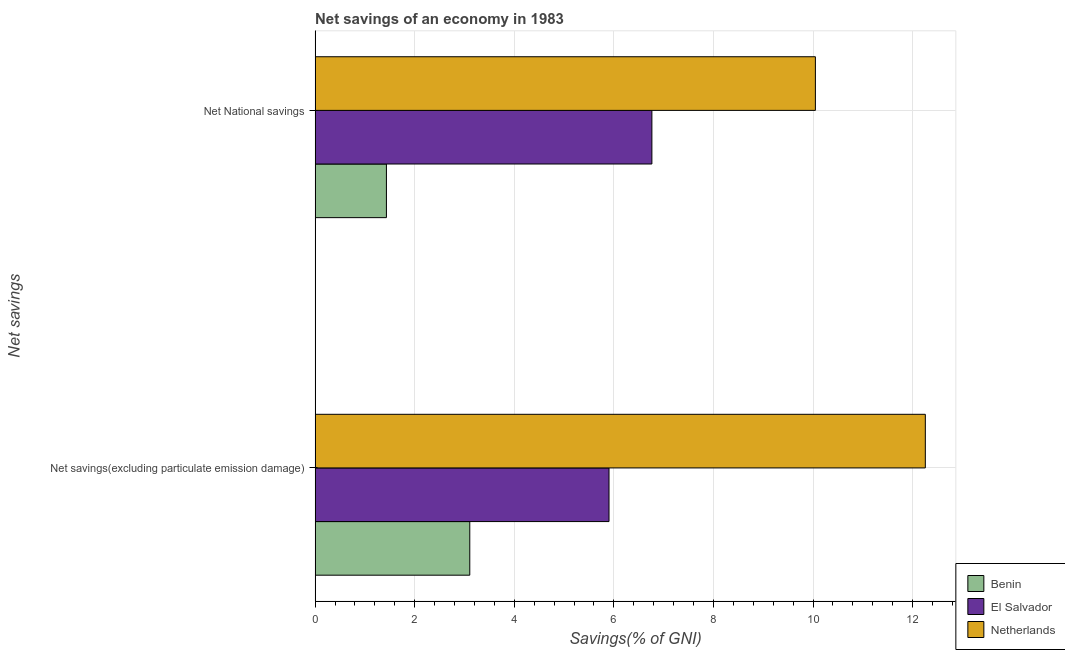How many groups of bars are there?
Offer a very short reply. 2. Are the number of bars on each tick of the Y-axis equal?
Provide a short and direct response. Yes. How many bars are there on the 1st tick from the top?
Make the answer very short. 3. What is the label of the 2nd group of bars from the top?
Provide a short and direct response. Net savings(excluding particulate emission damage). What is the net national savings in Netherlands?
Offer a terse response. 10.05. Across all countries, what is the maximum net savings(excluding particulate emission damage)?
Keep it short and to the point. 12.26. Across all countries, what is the minimum net national savings?
Make the answer very short. 1.43. In which country was the net national savings maximum?
Provide a succinct answer. Netherlands. In which country was the net savings(excluding particulate emission damage) minimum?
Your answer should be very brief. Benin. What is the total net national savings in the graph?
Your response must be concise. 18.24. What is the difference between the net savings(excluding particulate emission damage) in Benin and that in Netherlands?
Give a very brief answer. -9.15. What is the difference between the net national savings in Benin and the net savings(excluding particulate emission damage) in El Salvador?
Keep it short and to the point. -4.47. What is the average net savings(excluding particulate emission damage) per country?
Provide a succinct answer. 7.09. What is the difference between the net savings(excluding particulate emission damage) and net national savings in El Salvador?
Your answer should be very brief. -0.86. In how many countries, is the net national savings greater than 12 %?
Offer a terse response. 0. What is the ratio of the net national savings in Netherlands to that in El Salvador?
Keep it short and to the point. 1.49. Is the net national savings in El Salvador less than that in Netherlands?
Ensure brevity in your answer.  Yes. In how many countries, is the net national savings greater than the average net national savings taken over all countries?
Offer a very short reply. 2. What does the 2nd bar from the bottom in Net savings(excluding particulate emission damage) represents?
Ensure brevity in your answer.  El Salvador. How many bars are there?
Offer a very short reply. 6. What is the difference between two consecutive major ticks on the X-axis?
Provide a short and direct response. 2. Are the values on the major ticks of X-axis written in scientific E-notation?
Offer a terse response. No. Does the graph contain any zero values?
Give a very brief answer. No. Does the graph contain grids?
Provide a succinct answer. Yes. Where does the legend appear in the graph?
Give a very brief answer. Bottom right. How many legend labels are there?
Your answer should be compact. 3. How are the legend labels stacked?
Ensure brevity in your answer.  Vertical. What is the title of the graph?
Your response must be concise. Net savings of an economy in 1983. Does "Liberia" appear as one of the legend labels in the graph?
Give a very brief answer. No. What is the label or title of the X-axis?
Your answer should be compact. Savings(% of GNI). What is the label or title of the Y-axis?
Provide a succinct answer. Net savings. What is the Savings(% of GNI) of Benin in Net savings(excluding particulate emission damage)?
Offer a very short reply. 3.11. What is the Savings(% of GNI) of El Salvador in Net savings(excluding particulate emission damage)?
Offer a very short reply. 5.9. What is the Savings(% of GNI) in Netherlands in Net savings(excluding particulate emission damage)?
Your answer should be very brief. 12.26. What is the Savings(% of GNI) of Benin in Net National savings?
Your answer should be very brief. 1.43. What is the Savings(% of GNI) of El Salvador in Net National savings?
Ensure brevity in your answer.  6.76. What is the Savings(% of GNI) in Netherlands in Net National savings?
Keep it short and to the point. 10.05. Across all Net savings, what is the maximum Savings(% of GNI) in Benin?
Make the answer very short. 3.11. Across all Net savings, what is the maximum Savings(% of GNI) of El Salvador?
Your answer should be compact. 6.76. Across all Net savings, what is the maximum Savings(% of GNI) of Netherlands?
Keep it short and to the point. 12.26. Across all Net savings, what is the minimum Savings(% of GNI) in Benin?
Offer a terse response. 1.43. Across all Net savings, what is the minimum Savings(% of GNI) of El Salvador?
Your response must be concise. 5.9. Across all Net savings, what is the minimum Savings(% of GNI) of Netherlands?
Make the answer very short. 10.05. What is the total Savings(% of GNI) of Benin in the graph?
Provide a succinct answer. 4.54. What is the total Savings(% of GNI) of El Salvador in the graph?
Your answer should be compact. 12.67. What is the total Savings(% of GNI) in Netherlands in the graph?
Offer a very short reply. 22.3. What is the difference between the Savings(% of GNI) of Benin in Net savings(excluding particulate emission damage) and that in Net National savings?
Provide a succinct answer. 1.67. What is the difference between the Savings(% of GNI) of El Salvador in Net savings(excluding particulate emission damage) and that in Net National savings?
Make the answer very short. -0.86. What is the difference between the Savings(% of GNI) of Netherlands in Net savings(excluding particulate emission damage) and that in Net National savings?
Ensure brevity in your answer.  2.21. What is the difference between the Savings(% of GNI) in Benin in Net savings(excluding particulate emission damage) and the Savings(% of GNI) in El Salvador in Net National savings?
Ensure brevity in your answer.  -3.66. What is the difference between the Savings(% of GNI) of Benin in Net savings(excluding particulate emission damage) and the Savings(% of GNI) of Netherlands in Net National savings?
Offer a terse response. -6.94. What is the difference between the Savings(% of GNI) of El Salvador in Net savings(excluding particulate emission damage) and the Savings(% of GNI) of Netherlands in Net National savings?
Ensure brevity in your answer.  -4.14. What is the average Savings(% of GNI) of Benin per Net savings?
Make the answer very short. 2.27. What is the average Savings(% of GNI) in El Salvador per Net savings?
Give a very brief answer. 6.33. What is the average Savings(% of GNI) in Netherlands per Net savings?
Keep it short and to the point. 11.15. What is the difference between the Savings(% of GNI) in Benin and Savings(% of GNI) in El Salvador in Net savings(excluding particulate emission damage)?
Your answer should be very brief. -2.8. What is the difference between the Savings(% of GNI) of Benin and Savings(% of GNI) of Netherlands in Net savings(excluding particulate emission damage)?
Give a very brief answer. -9.15. What is the difference between the Savings(% of GNI) in El Salvador and Savings(% of GNI) in Netherlands in Net savings(excluding particulate emission damage)?
Your answer should be very brief. -6.35. What is the difference between the Savings(% of GNI) of Benin and Savings(% of GNI) of El Salvador in Net National savings?
Ensure brevity in your answer.  -5.33. What is the difference between the Savings(% of GNI) of Benin and Savings(% of GNI) of Netherlands in Net National savings?
Provide a short and direct response. -8.62. What is the difference between the Savings(% of GNI) of El Salvador and Savings(% of GNI) of Netherlands in Net National savings?
Give a very brief answer. -3.28. What is the ratio of the Savings(% of GNI) in Benin in Net savings(excluding particulate emission damage) to that in Net National savings?
Keep it short and to the point. 2.17. What is the ratio of the Savings(% of GNI) in El Salvador in Net savings(excluding particulate emission damage) to that in Net National savings?
Provide a short and direct response. 0.87. What is the ratio of the Savings(% of GNI) of Netherlands in Net savings(excluding particulate emission damage) to that in Net National savings?
Your response must be concise. 1.22. What is the difference between the highest and the second highest Savings(% of GNI) in Benin?
Your answer should be very brief. 1.67. What is the difference between the highest and the second highest Savings(% of GNI) in El Salvador?
Your answer should be very brief. 0.86. What is the difference between the highest and the second highest Savings(% of GNI) in Netherlands?
Keep it short and to the point. 2.21. What is the difference between the highest and the lowest Savings(% of GNI) of Benin?
Provide a short and direct response. 1.67. What is the difference between the highest and the lowest Savings(% of GNI) in El Salvador?
Keep it short and to the point. 0.86. What is the difference between the highest and the lowest Savings(% of GNI) of Netherlands?
Your response must be concise. 2.21. 